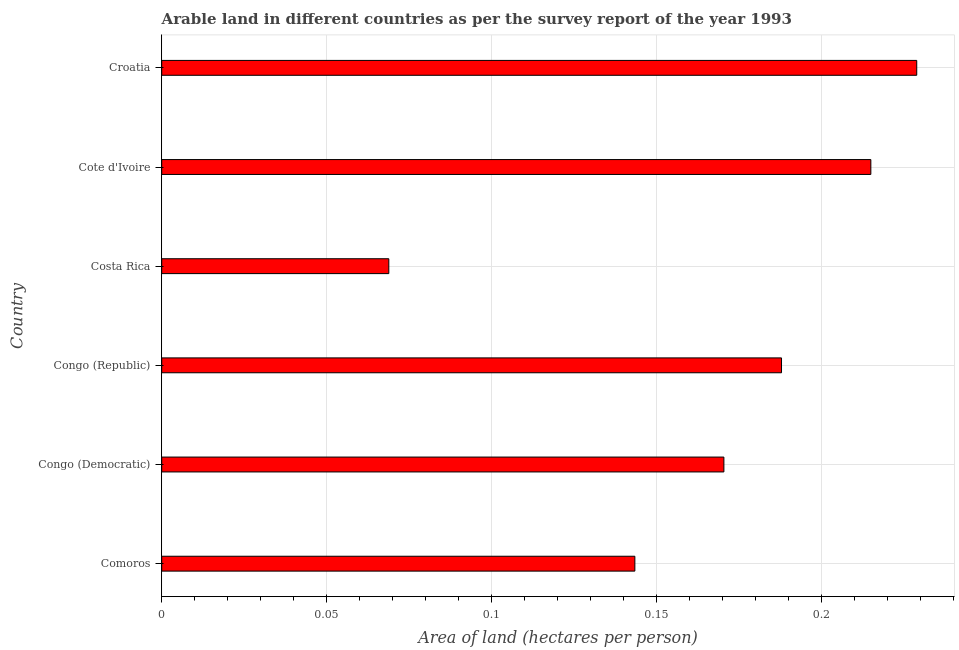Does the graph contain any zero values?
Your answer should be compact. No. Does the graph contain grids?
Offer a very short reply. Yes. What is the title of the graph?
Offer a very short reply. Arable land in different countries as per the survey report of the year 1993. What is the label or title of the X-axis?
Your answer should be very brief. Area of land (hectares per person). What is the area of arable land in Congo (Republic)?
Give a very brief answer. 0.19. Across all countries, what is the maximum area of arable land?
Your response must be concise. 0.23. Across all countries, what is the minimum area of arable land?
Your answer should be very brief. 0.07. In which country was the area of arable land maximum?
Your answer should be compact. Croatia. In which country was the area of arable land minimum?
Offer a terse response. Costa Rica. What is the sum of the area of arable land?
Your response must be concise. 1.01. What is the difference between the area of arable land in Congo (Democratic) and Cote d'Ivoire?
Keep it short and to the point. -0.04. What is the average area of arable land per country?
Provide a succinct answer. 0.17. What is the median area of arable land?
Your answer should be compact. 0.18. In how many countries, is the area of arable land greater than 0.06 hectares per person?
Provide a short and direct response. 6. What is the ratio of the area of arable land in Congo (Republic) to that in Costa Rica?
Your response must be concise. 2.73. Is the area of arable land in Congo (Democratic) less than that in Croatia?
Provide a succinct answer. Yes. Is the difference between the area of arable land in Congo (Democratic) and Croatia greater than the difference between any two countries?
Give a very brief answer. No. What is the difference between the highest and the second highest area of arable land?
Make the answer very short. 0.01. What is the difference between the highest and the lowest area of arable land?
Provide a short and direct response. 0.16. Are all the bars in the graph horizontal?
Provide a succinct answer. Yes. What is the difference between two consecutive major ticks on the X-axis?
Your answer should be compact. 0.05. What is the Area of land (hectares per person) of Comoros?
Keep it short and to the point. 0.14. What is the Area of land (hectares per person) in Congo (Democratic)?
Give a very brief answer. 0.17. What is the Area of land (hectares per person) in Congo (Republic)?
Offer a very short reply. 0.19. What is the Area of land (hectares per person) of Costa Rica?
Give a very brief answer. 0.07. What is the Area of land (hectares per person) of Cote d'Ivoire?
Give a very brief answer. 0.21. What is the Area of land (hectares per person) in Croatia?
Offer a terse response. 0.23. What is the difference between the Area of land (hectares per person) in Comoros and Congo (Democratic)?
Make the answer very short. -0.03. What is the difference between the Area of land (hectares per person) in Comoros and Congo (Republic)?
Your answer should be very brief. -0.04. What is the difference between the Area of land (hectares per person) in Comoros and Costa Rica?
Provide a succinct answer. 0.07. What is the difference between the Area of land (hectares per person) in Comoros and Cote d'Ivoire?
Keep it short and to the point. -0.07. What is the difference between the Area of land (hectares per person) in Comoros and Croatia?
Keep it short and to the point. -0.09. What is the difference between the Area of land (hectares per person) in Congo (Democratic) and Congo (Republic)?
Ensure brevity in your answer.  -0.02. What is the difference between the Area of land (hectares per person) in Congo (Democratic) and Costa Rica?
Your answer should be compact. 0.1. What is the difference between the Area of land (hectares per person) in Congo (Democratic) and Cote d'Ivoire?
Ensure brevity in your answer.  -0.04. What is the difference between the Area of land (hectares per person) in Congo (Democratic) and Croatia?
Give a very brief answer. -0.06. What is the difference between the Area of land (hectares per person) in Congo (Republic) and Costa Rica?
Provide a succinct answer. 0.12. What is the difference between the Area of land (hectares per person) in Congo (Republic) and Cote d'Ivoire?
Your response must be concise. -0.03. What is the difference between the Area of land (hectares per person) in Congo (Republic) and Croatia?
Offer a terse response. -0.04. What is the difference between the Area of land (hectares per person) in Costa Rica and Cote d'Ivoire?
Your response must be concise. -0.15. What is the difference between the Area of land (hectares per person) in Costa Rica and Croatia?
Ensure brevity in your answer.  -0.16. What is the difference between the Area of land (hectares per person) in Cote d'Ivoire and Croatia?
Provide a short and direct response. -0.01. What is the ratio of the Area of land (hectares per person) in Comoros to that in Congo (Democratic)?
Ensure brevity in your answer.  0.84. What is the ratio of the Area of land (hectares per person) in Comoros to that in Congo (Republic)?
Offer a very short reply. 0.76. What is the ratio of the Area of land (hectares per person) in Comoros to that in Costa Rica?
Your answer should be compact. 2.08. What is the ratio of the Area of land (hectares per person) in Comoros to that in Cote d'Ivoire?
Offer a very short reply. 0.67. What is the ratio of the Area of land (hectares per person) in Comoros to that in Croatia?
Keep it short and to the point. 0.63. What is the ratio of the Area of land (hectares per person) in Congo (Democratic) to that in Congo (Republic)?
Provide a succinct answer. 0.91. What is the ratio of the Area of land (hectares per person) in Congo (Democratic) to that in Costa Rica?
Your answer should be very brief. 2.48. What is the ratio of the Area of land (hectares per person) in Congo (Democratic) to that in Cote d'Ivoire?
Your answer should be compact. 0.79. What is the ratio of the Area of land (hectares per person) in Congo (Democratic) to that in Croatia?
Offer a very short reply. 0.74. What is the ratio of the Area of land (hectares per person) in Congo (Republic) to that in Costa Rica?
Provide a short and direct response. 2.73. What is the ratio of the Area of land (hectares per person) in Congo (Republic) to that in Cote d'Ivoire?
Offer a very short reply. 0.87. What is the ratio of the Area of land (hectares per person) in Congo (Republic) to that in Croatia?
Keep it short and to the point. 0.82. What is the ratio of the Area of land (hectares per person) in Costa Rica to that in Cote d'Ivoire?
Provide a succinct answer. 0.32. What is the ratio of the Area of land (hectares per person) in Costa Rica to that in Croatia?
Offer a very short reply. 0.3. What is the ratio of the Area of land (hectares per person) in Cote d'Ivoire to that in Croatia?
Provide a short and direct response. 0.94. 